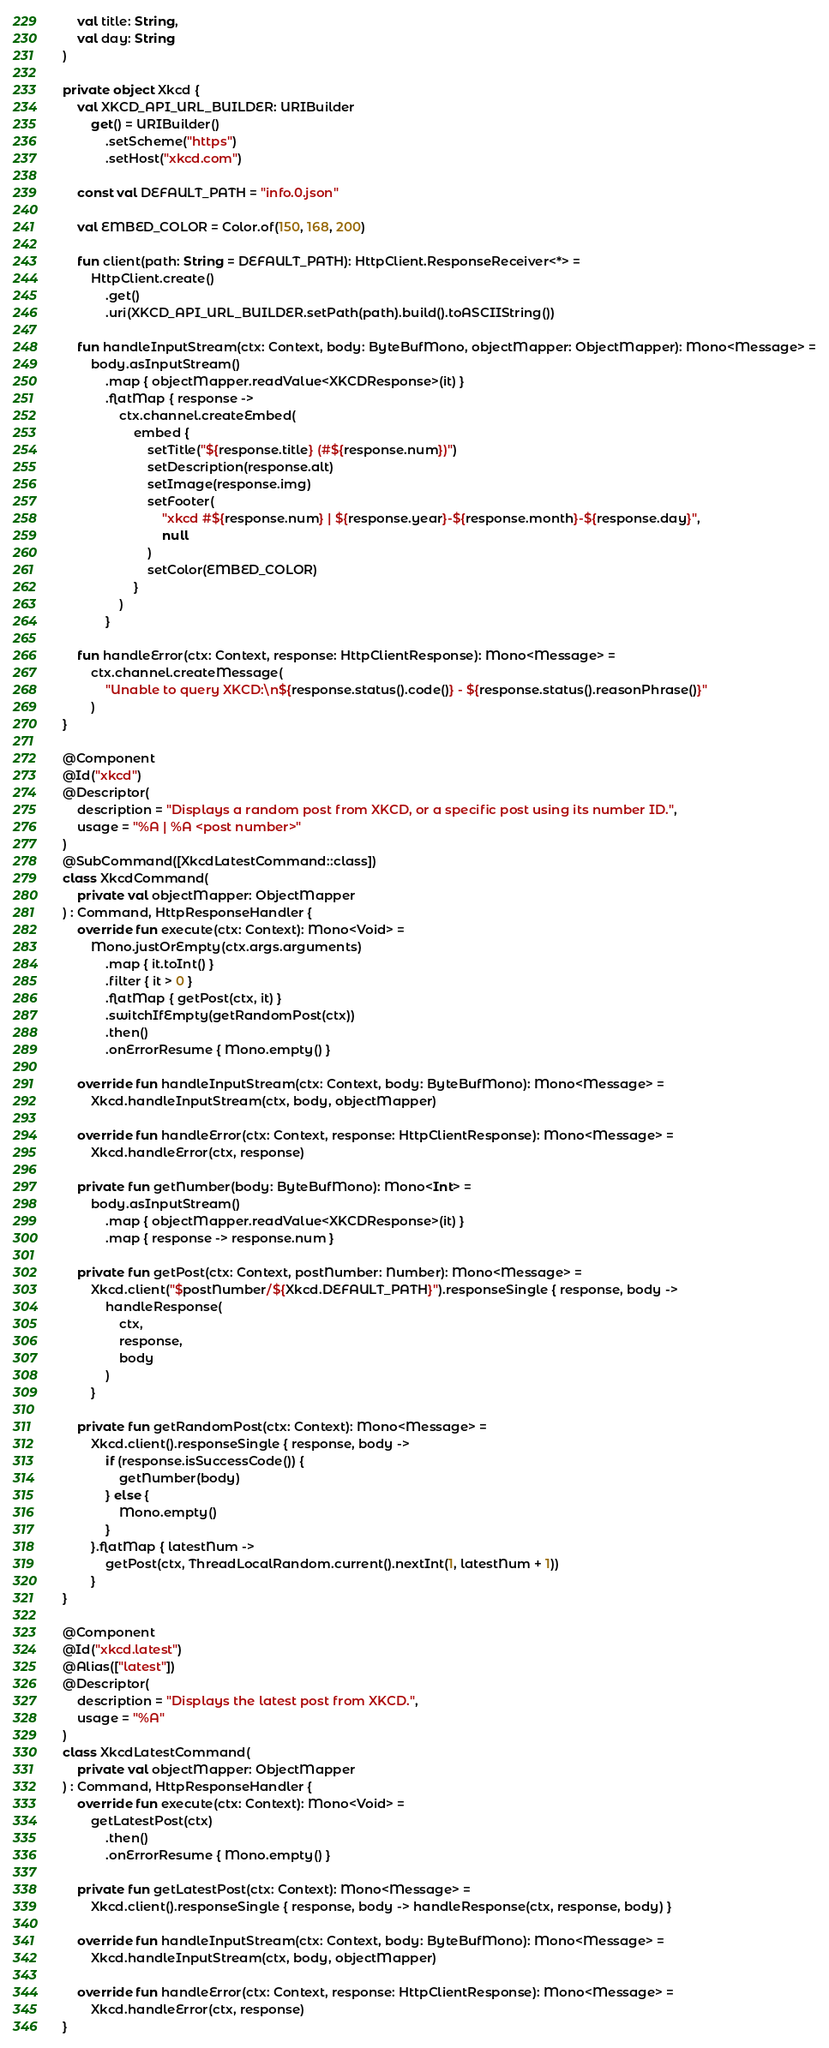<code> <loc_0><loc_0><loc_500><loc_500><_Kotlin_>    val title: String,
    val day: String
)

private object Xkcd {
    val XKCD_API_URL_BUILDER: URIBuilder
        get() = URIBuilder()
            .setScheme("https")
            .setHost("xkcd.com")

    const val DEFAULT_PATH = "info.0.json"

    val EMBED_COLOR = Color.of(150, 168, 200)

    fun client(path: String = DEFAULT_PATH): HttpClient.ResponseReceiver<*> =
        HttpClient.create()
            .get()
            .uri(XKCD_API_URL_BUILDER.setPath(path).build().toASCIIString())

    fun handleInputStream(ctx: Context, body: ByteBufMono, objectMapper: ObjectMapper): Mono<Message> =
        body.asInputStream()
            .map { objectMapper.readValue<XKCDResponse>(it) }
            .flatMap { response ->
                ctx.channel.createEmbed(
                    embed {
                        setTitle("${response.title} (#${response.num})")
                        setDescription(response.alt)
                        setImage(response.img)
                        setFooter(
                            "xkcd #${response.num} | ${response.year}-${response.month}-${response.day}",
                            null
                        )
                        setColor(EMBED_COLOR)
                    }
                )
            }

    fun handleError(ctx: Context, response: HttpClientResponse): Mono<Message> =
        ctx.channel.createMessage(
            "Unable to query XKCD:\n${response.status().code()} - ${response.status().reasonPhrase()}"
        )
}

@Component
@Id("xkcd")
@Descriptor(
    description = "Displays a random post from XKCD, or a specific post using its number ID.",
    usage = "%A | %A <post number>"
)
@SubCommand([XkcdLatestCommand::class])
class XkcdCommand(
    private val objectMapper: ObjectMapper
) : Command, HttpResponseHandler {
    override fun execute(ctx: Context): Mono<Void> =
        Mono.justOrEmpty(ctx.args.arguments)
            .map { it.toInt() }
            .filter { it > 0 }
            .flatMap { getPost(ctx, it) }
            .switchIfEmpty(getRandomPost(ctx))
            .then()
            .onErrorResume { Mono.empty() }

    override fun handleInputStream(ctx: Context, body: ByteBufMono): Mono<Message> =
        Xkcd.handleInputStream(ctx, body, objectMapper)

    override fun handleError(ctx: Context, response: HttpClientResponse): Mono<Message> =
        Xkcd.handleError(ctx, response)

    private fun getNumber(body: ByteBufMono): Mono<Int> =
        body.asInputStream()
            .map { objectMapper.readValue<XKCDResponse>(it) }
            .map { response -> response.num }

    private fun getPost(ctx: Context, postNumber: Number): Mono<Message> =
        Xkcd.client("$postNumber/${Xkcd.DEFAULT_PATH}").responseSingle { response, body ->
            handleResponse(
                ctx,
                response,
                body
            )
        }

    private fun getRandomPost(ctx: Context): Mono<Message> =
        Xkcd.client().responseSingle { response, body ->
            if (response.isSuccessCode()) {
                getNumber(body)
            } else {
                Mono.empty()
            }
        }.flatMap { latestNum ->
            getPost(ctx, ThreadLocalRandom.current().nextInt(1, latestNum + 1))
        }
}

@Component
@Id("xkcd.latest")
@Alias(["latest"])
@Descriptor(
    description = "Displays the latest post from XKCD.",
    usage = "%A"
)
class XkcdLatestCommand(
    private val objectMapper: ObjectMapper
) : Command, HttpResponseHandler {
    override fun execute(ctx: Context): Mono<Void> =
        getLatestPost(ctx)
            .then()
            .onErrorResume { Mono.empty() }

    private fun getLatestPost(ctx: Context): Mono<Message> =
        Xkcd.client().responseSingle { response, body -> handleResponse(ctx, response, body) }

    override fun handleInputStream(ctx: Context, body: ByteBufMono): Mono<Message> =
        Xkcd.handleInputStream(ctx, body, objectMapper)

    override fun handleError(ctx: Context, response: HttpClientResponse): Mono<Message> =
        Xkcd.handleError(ctx, response)
}
</code> 